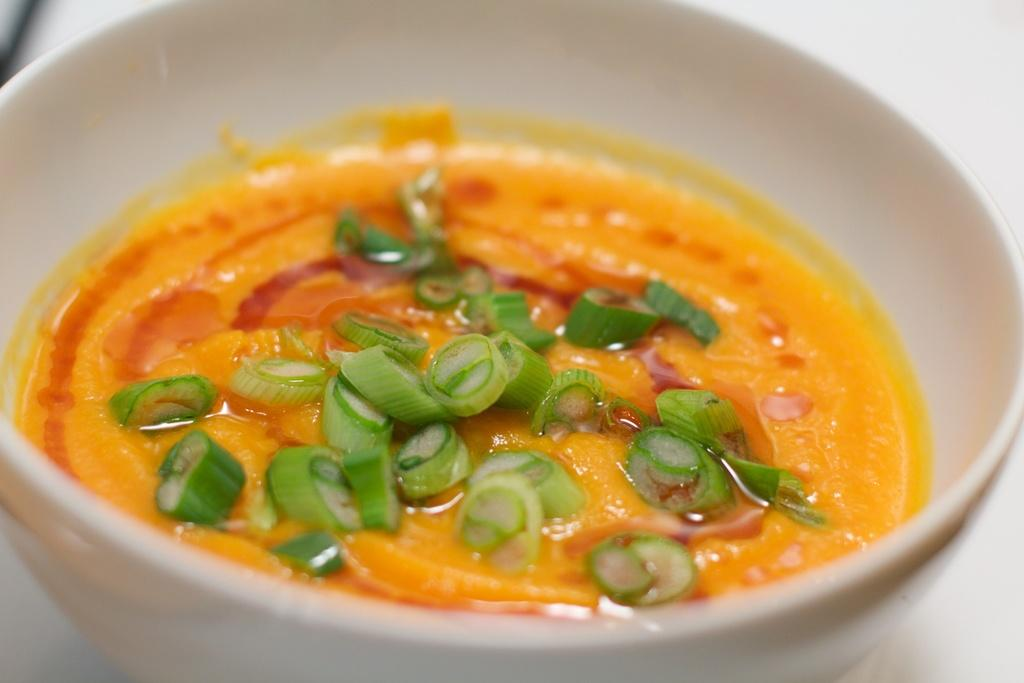What is the main subject of the image? There is a food item in the image. How is the food item contained in the image? The food item is in a bowl. What color is the bowl? The bowl is white in color. What type of button can be seen on the food item in the image? There is no button present on the food item in the image. 